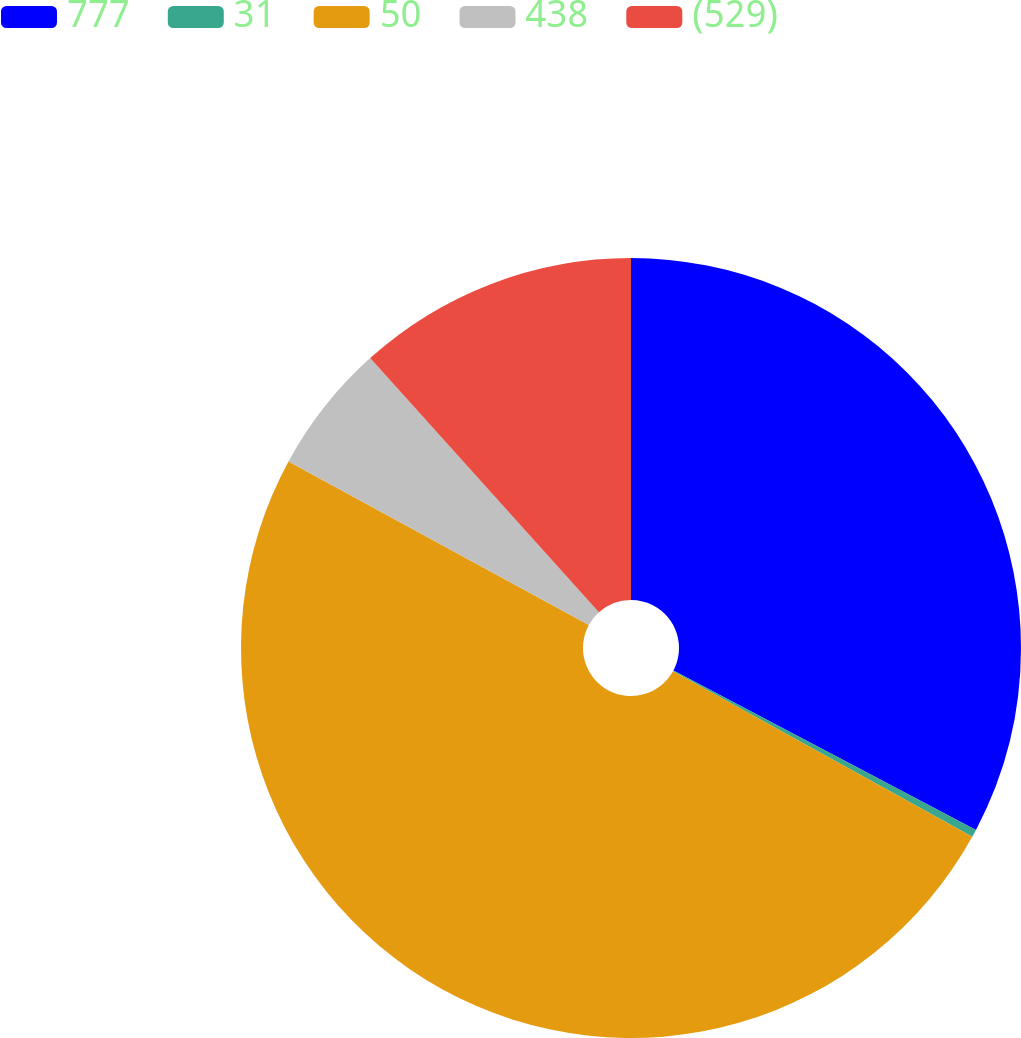Convert chart to OTSL. <chart><loc_0><loc_0><loc_500><loc_500><pie_chart><fcel>777<fcel>31<fcel>50<fcel>438<fcel>(529)<nl><fcel>32.72%<fcel>0.32%<fcel>49.89%<fcel>5.4%<fcel>11.66%<nl></chart> 